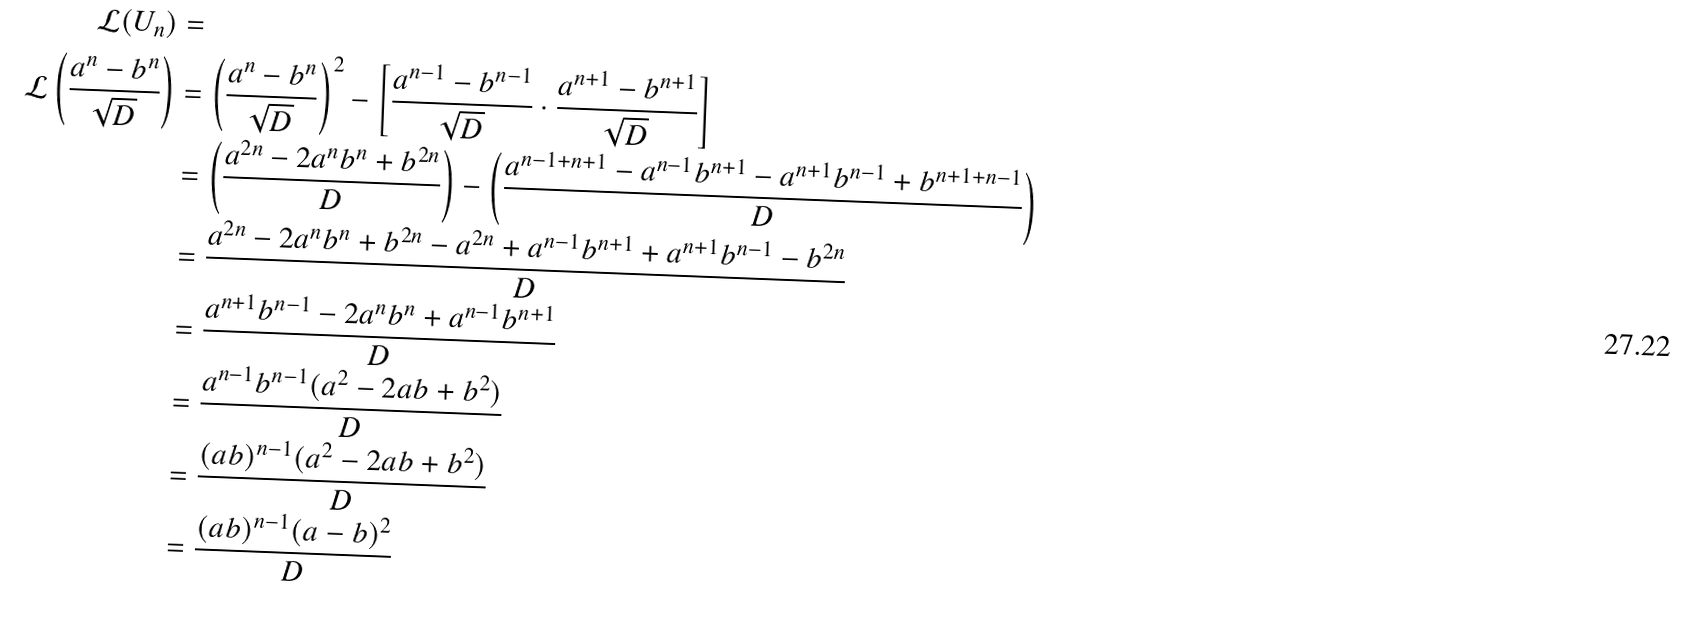<formula> <loc_0><loc_0><loc_500><loc_500>\mathcal { L } ( U _ { n } ) & = \\ \mathcal { L } \left ( \frac { a ^ { n } - b ^ { n } } { \sqrt { D } } \right ) & = \left ( \frac { a ^ { n } - b ^ { n } } { \sqrt { D } } \right ) ^ { 2 } - \left [ \frac { a ^ { n - 1 } - b ^ { n - 1 } } { \sqrt { D } } \cdot \frac { a ^ { n + 1 } - b ^ { n + 1 } } { \sqrt { D } } \right ] \\ & = \left ( \frac { a ^ { 2 n } - 2 a ^ { n } b ^ { n } + b ^ { 2 n } } { D } \right ) - \left ( \frac { a ^ { n - 1 + n + 1 } - a ^ { n - 1 } b ^ { n + 1 } - a ^ { n + 1 } b ^ { n - 1 } + b ^ { n + 1 + n - 1 } } { D } \right ) \\ & = \frac { a ^ { 2 n } - 2 a ^ { n } b ^ { n } + b ^ { 2 n } - a ^ { 2 n } + a ^ { n - 1 } b ^ { n + 1 } + a ^ { n + 1 } b ^ { n - 1 } - b ^ { 2 n } } { D } \\ & = \frac { a ^ { n + 1 } b ^ { n - 1 } - 2 a ^ { n } b ^ { n } + a ^ { n - 1 } b ^ { n + 1 } } { D } \\ & = \frac { a ^ { n - 1 } b ^ { n - 1 } ( a ^ { 2 } - 2 a b + b ^ { 2 } ) } { D } \\ & = \frac { ( a b ) ^ { n - 1 } ( a ^ { 2 } - 2 a b + b ^ { 2 } ) } { D } \\ & = \frac { ( a b ) ^ { n - 1 } ( a - b ) ^ { 2 } } { D } \\</formula> 